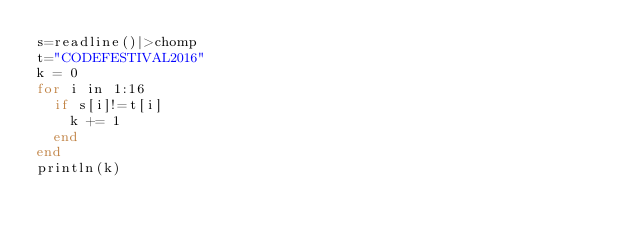Convert code to text. <code><loc_0><loc_0><loc_500><loc_500><_Julia_>s=readline()|>chomp
t="CODEFESTIVAL2016"
k = 0
for i in 1:16
  if s[i]!=t[i]
    k += 1
  end
end
println(k)</code> 